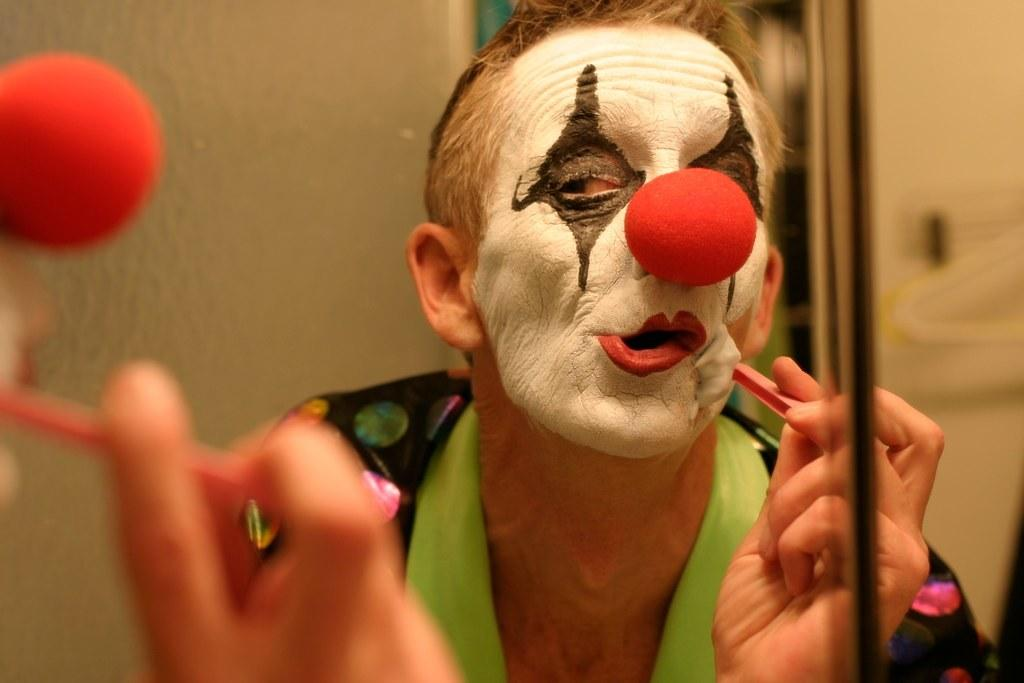What is the main subject of the image? There is a person in the image. What is the person doing in the image? The person is holding an object. Can you describe the background of the image? The background of the image is blurry. What else can be seen in the front of the image? A person's hand is visible in the front of the image. What is the hand holding? The hand is holding an object. What type of liquid can be seen flowing down the mountain in the image? There is no mountain or liquid present in the image. What kind of carriage is visible in the image? There is no carriage present in the image. 